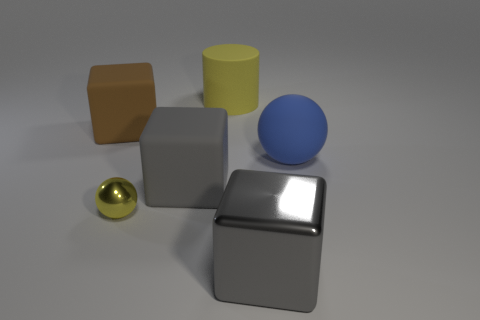Add 1 large metallic things. How many objects exist? 7 Subtract all cylinders. How many objects are left? 5 Subtract all brown matte balls. Subtract all yellow balls. How many objects are left? 5 Add 6 cylinders. How many cylinders are left? 7 Add 6 blue things. How many blue things exist? 7 Subtract 0 red cylinders. How many objects are left? 6 